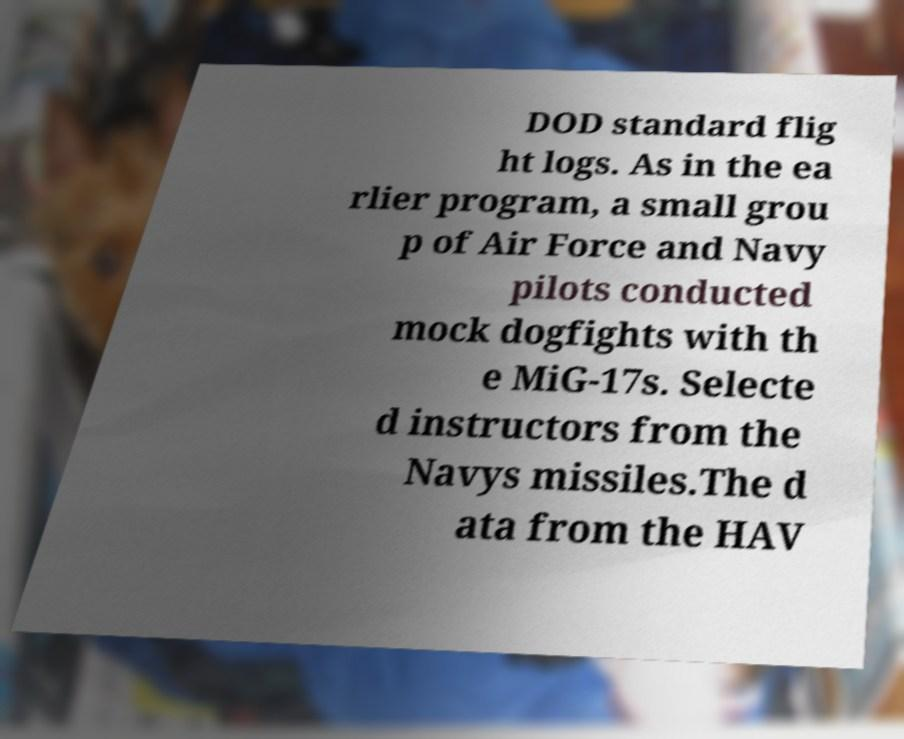Can you read and provide the text displayed in the image?This photo seems to have some interesting text. Can you extract and type it out for me? DOD standard flig ht logs. As in the ea rlier program, a small grou p of Air Force and Navy pilots conducted mock dogfights with th e MiG-17s. Selecte d instructors from the Navys missiles.The d ata from the HAV 